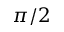<formula> <loc_0><loc_0><loc_500><loc_500>\pi / 2</formula> 